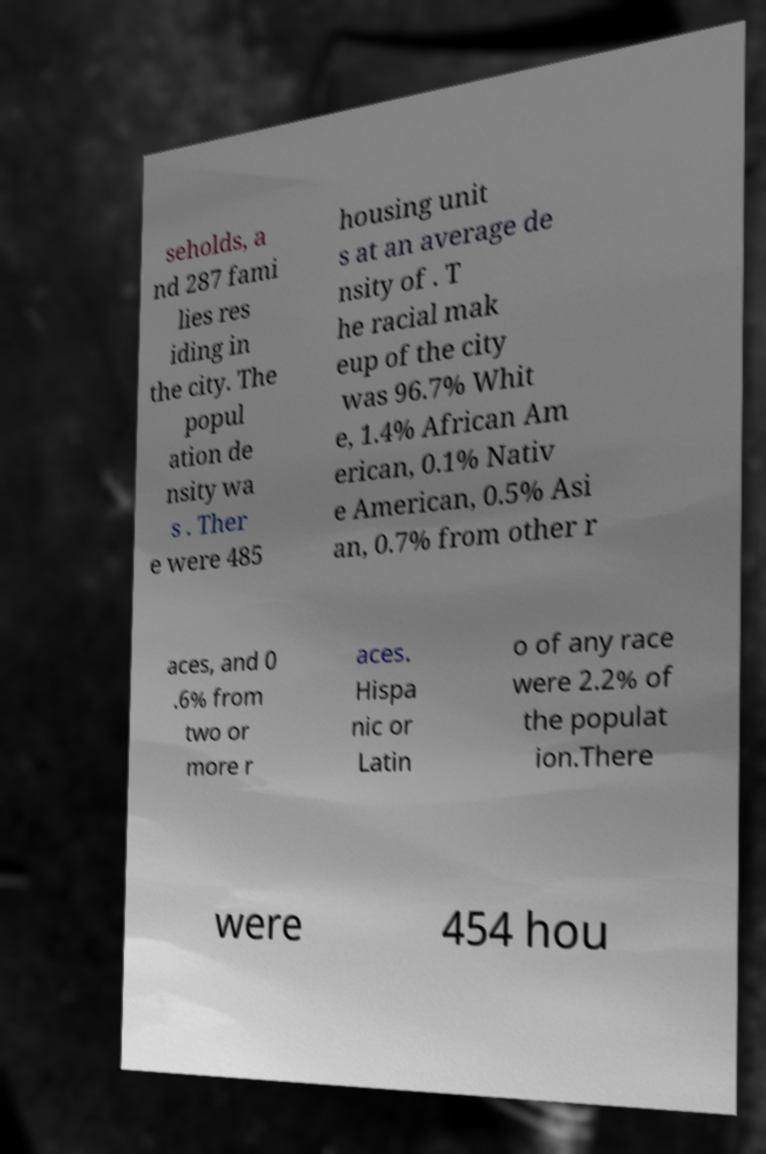Can you accurately transcribe the text from the provided image for me? seholds, a nd 287 fami lies res iding in the city. The popul ation de nsity wa s . Ther e were 485 housing unit s at an average de nsity of . T he racial mak eup of the city was 96.7% Whit e, 1.4% African Am erican, 0.1% Nativ e American, 0.5% Asi an, 0.7% from other r aces, and 0 .6% from two or more r aces. Hispa nic or Latin o of any race were 2.2% of the populat ion.There were 454 hou 